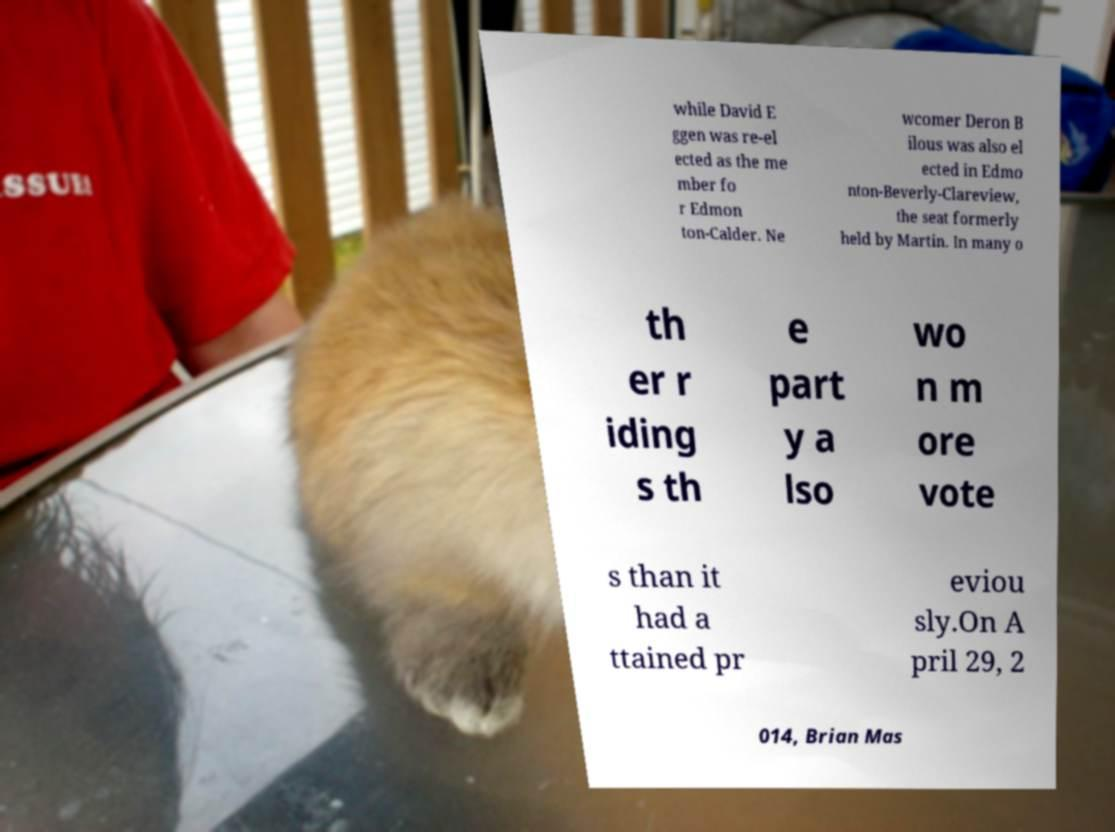For documentation purposes, I need the text within this image transcribed. Could you provide that? while David E ggen was re-el ected as the me mber fo r Edmon ton-Calder. Ne wcomer Deron B ilous was also el ected in Edmo nton-Beverly-Clareview, the seat formerly held by Martin. In many o th er r iding s th e part y a lso wo n m ore vote s than it had a ttained pr eviou sly.On A pril 29, 2 014, Brian Mas 